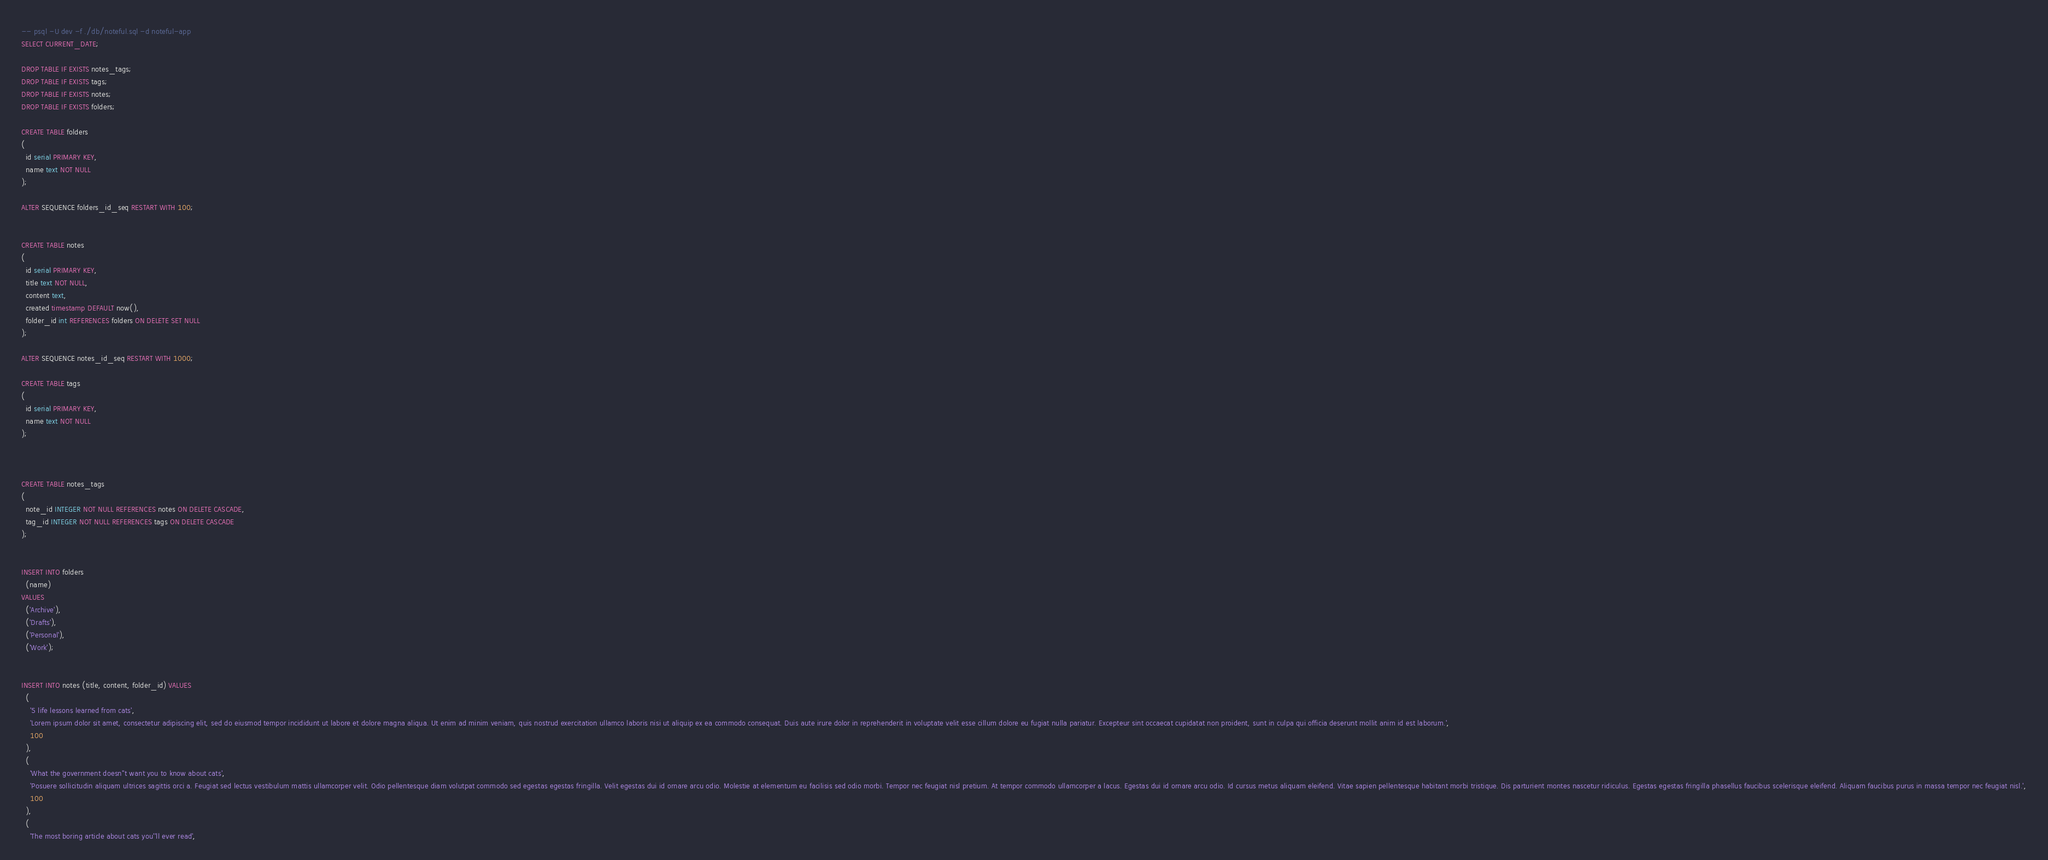<code> <loc_0><loc_0><loc_500><loc_500><_SQL_>-- psql -U dev -f ./db/noteful.sql -d noteful-app
SELECT CURRENT_DATE;

DROP TABLE IF EXISTS notes_tags;
DROP TABLE IF EXISTS tags;
DROP TABLE IF EXISTS notes;
DROP TABLE IF EXISTS folders;

CREATE TABLE folders
(
  id serial PRIMARY KEY,
  name text NOT NULL
);

ALTER SEQUENCE folders_id_seq RESTART WITH 100;


CREATE TABLE notes
(
  id serial PRIMARY KEY,
  title text NOT NULL,
  content text,
  created timestamp DEFAULT now(),
  folder_id int REFERENCES folders ON DELETE SET NULL
);

ALTER SEQUENCE notes_id_seq RESTART WITH 1000;

CREATE TABLE tags
(
  id serial PRIMARY KEY,
  name text NOT NULL
);



CREATE TABLE notes_tags
(
  note_id INTEGER NOT NULL REFERENCES notes ON DELETE CASCADE,
  tag_id INTEGER NOT NULL REFERENCES tags ON DELETE CASCADE
);


INSERT INTO folders
  (name)
VALUES
  ('Archive'),
  ('Drafts'),
  ('Personal'),
  ('Work');


INSERT INTO notes (title, content, folder_id) VALUES 
  (
    '5 life lessons learned from cats',
    'Lorem ipsum dolor sit amet, consectetur adipiscing elit, sed do eiusmod tempor incididunt ut labore et dolore magna aliqua. Ut enim ad minim veniam, quis nostrud exercitation ullamco laboris nisi ut aliquip ex ea commodo consequat. Duis aute irure dolor in reprehenderit in voluptate velit esse cillum dolore eu fugiat nulla pariatur. Excepteur sint occaecat cupidatat non proident, sunt in culpa qui officia deserunt mollit anim id est laborum.',
    100
  ),
  (
    'What the government doesn''t want you to know about cats',
    'Posuere sollicitudin aliquam ultrices sagittis orci a. Feugiat sed lectus vestibulum mattis ullamcorper velit. Odio pellentesque diam volutpat commodo sed egestas egestas fringilla. Velit egestas dui id ornare arcu odio. Molestie at elementum eu facilisis sed odio morbi. Tempor nec feugiat nisl pretium. At tempor commodo ullamcorper a lacus. Egestas dui id ornare arcu odio. Id cursus metus aliquam eleifend. Vitae sapien pellentesque habitant morbi tristique. Dis parturient montes nascetur ridiculus. Egestas egestas fringilla phasellus faucibus scelerisque eleifend. Aliquam faucibus purus in massa tempor nec feugiat nisl.',
    100
  ),
  (
    'The most boring article about cats you''ll ever read',</code> 